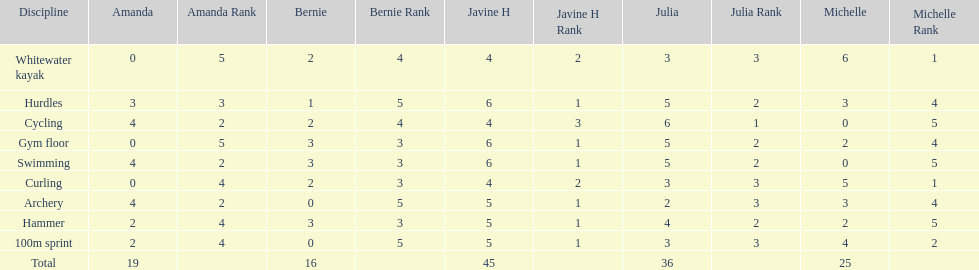What is the average score on 100m sprint? 2.8. 